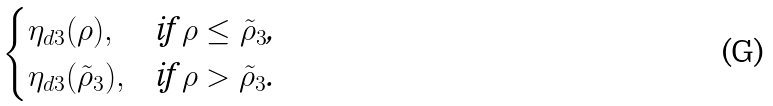<formula> <loc_0><loc_0><loc_500><loc_500>\begin{cases} \eta _ { d 3 } ( \rho ) , & \text {if $\rho \leq \tilde{\rho}_{3}$,} \\ \eta _ { d 3 } ( \tilde { \rho } _ { 3 } ) , & \text {if $\rho > \tilde{\rho}_{3}$.} \end{cases}</formula> 